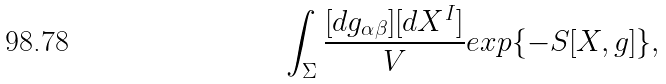<formula> <loc_0><loc_0><loc_500><loc_500>\int _ { \Sigma } \frac { [ d g _ { \alpha \beta } ] [ d X ^ { I } ] } { V } e x p \{ - S [ X , g ] \} ,</formula> 